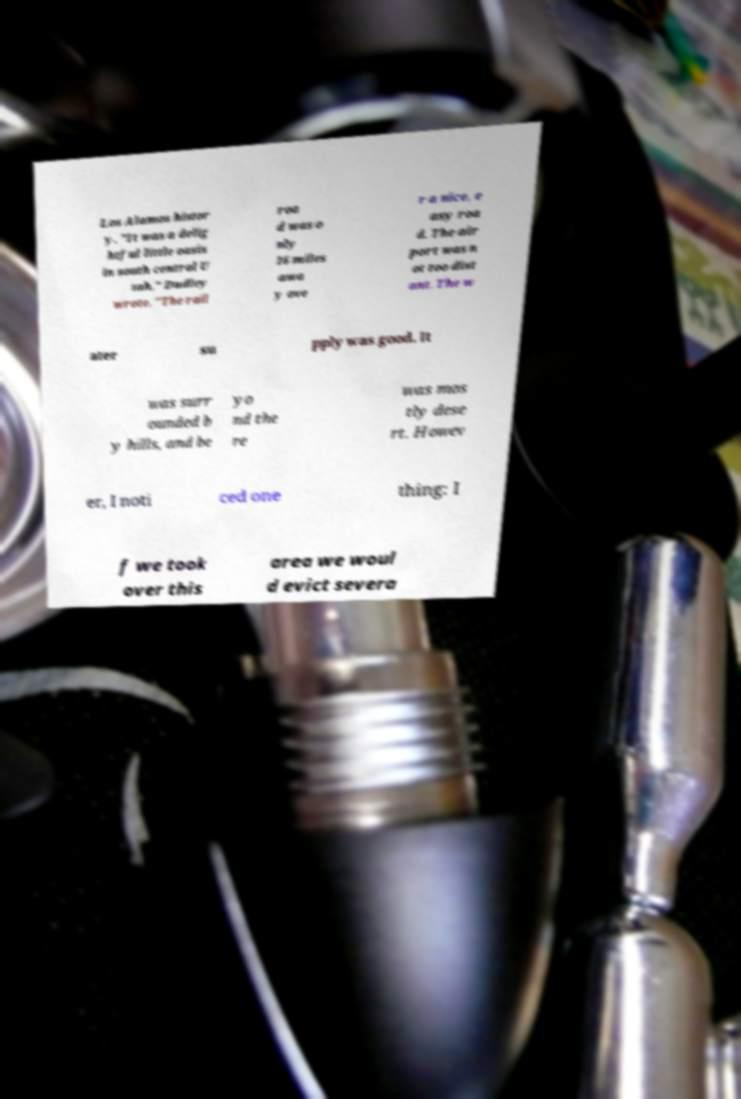Can you read and provide the text displayed in the image?This photo seems to have some interesting text. Can you extract and type it out for me? Los Alamos histor y. "It was a delig htful little oasis in south central U tah," Dudley wrote. "The rail roa d was o nly 16 miles awa y ove r a nice, e asy roa d. The air port was n ot too dist ant. The w ater su pply was good. It was surr ounded b y hills, and be yo nd the re was mos tly dese rt. Howev er, I noti ced one thing: I f we took over this area we woul d evict severa 